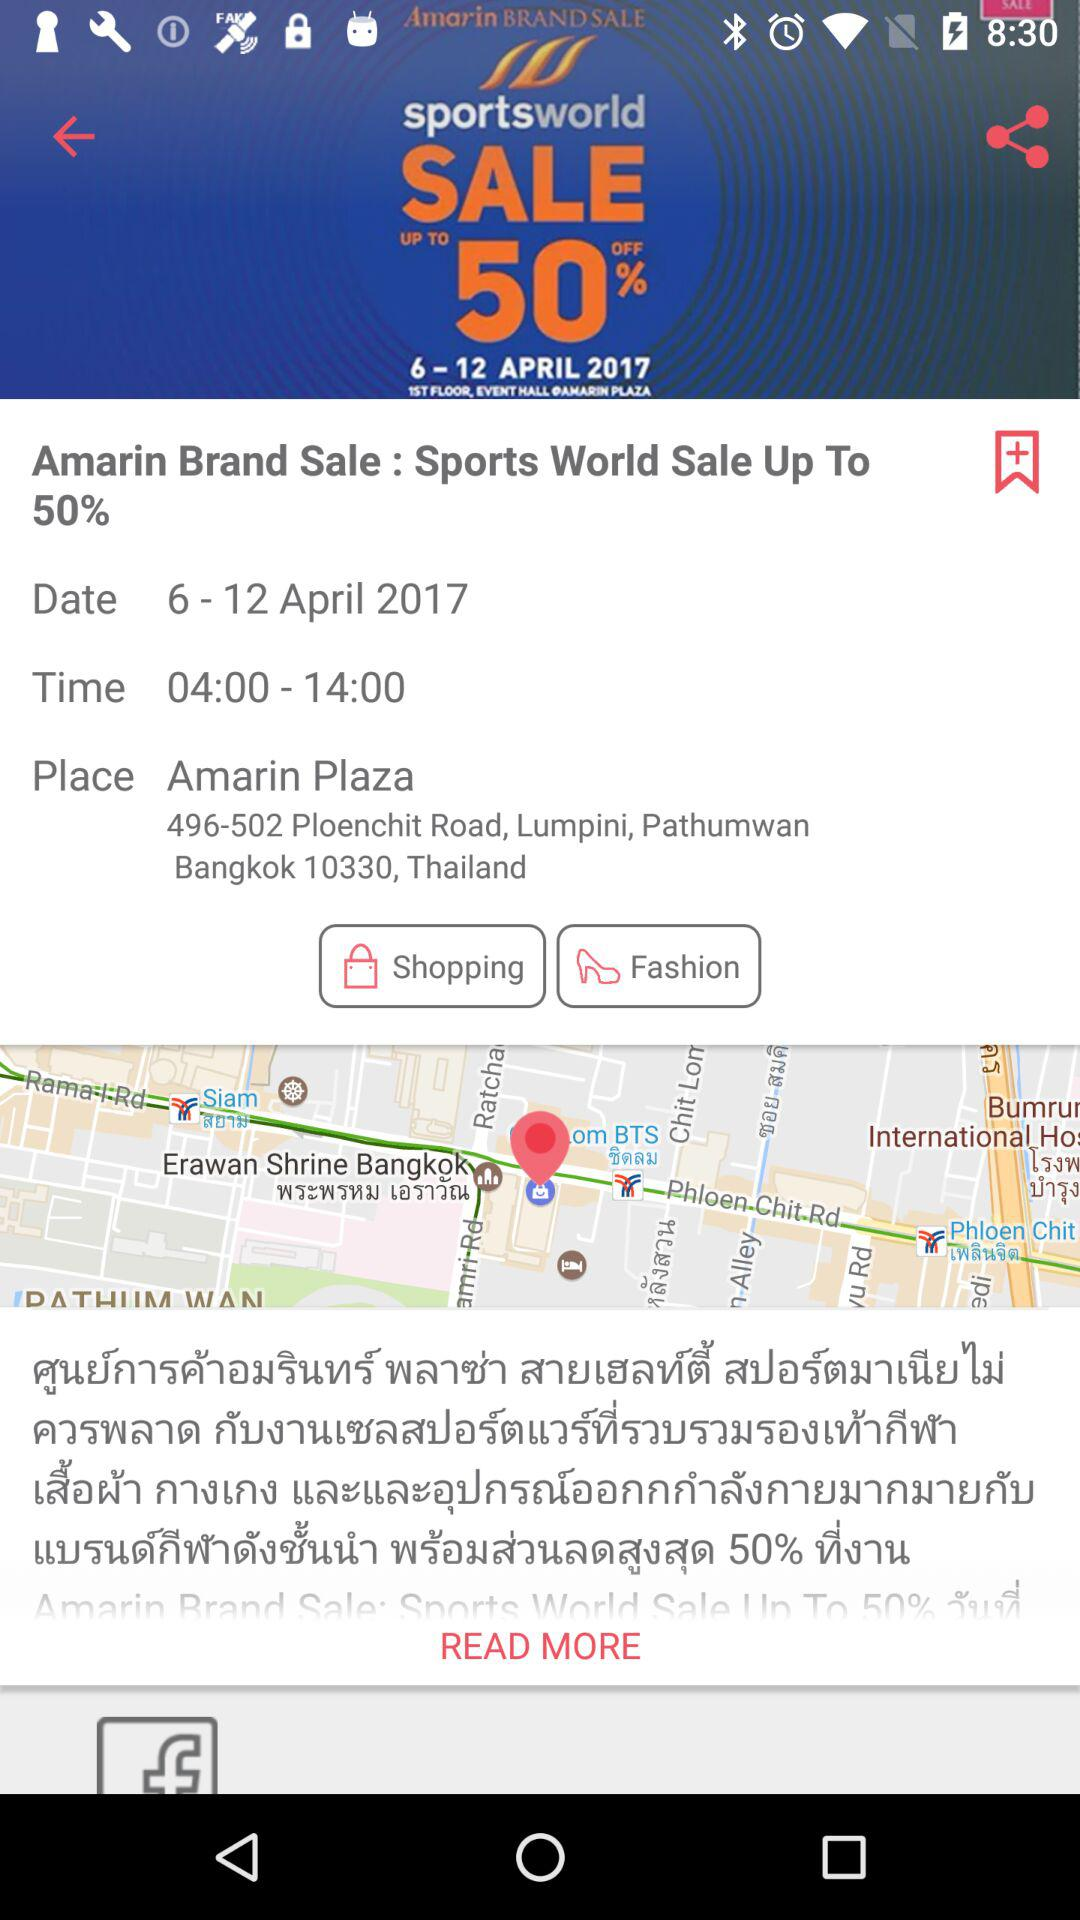What is the address? The address is 496-502 Ploenchit Road, Lumpini, Pathumwan, Bangkok 10330, Thailand. 